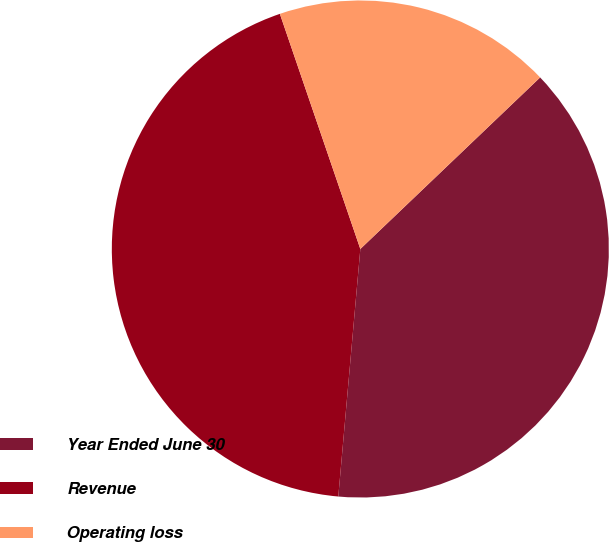Convert chart to OTSL. <chart><loc_0><loc_0><loc_500><loc_500><pie_chart><fcel>Year Ended June 30<fcel>Revenue<fcel>Operating loss<nl><fcel>38.54%<fcel>43.34%<fcel>18.12%<nl></chart> 